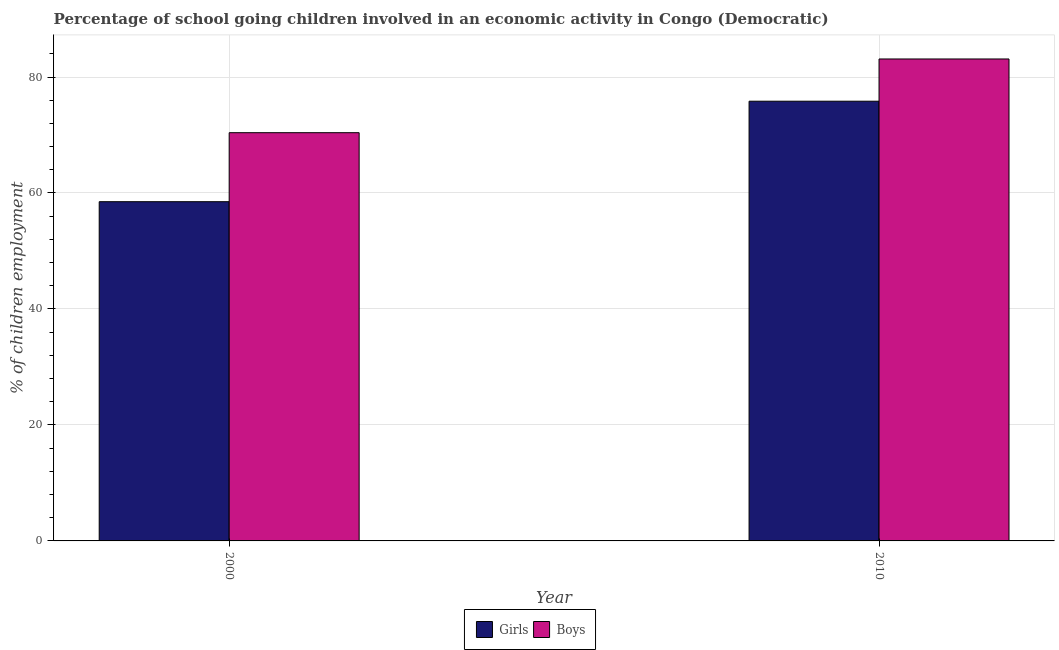How many groups of bars are there?
Offer a very short reply. 2. Are the number of bars per tick equal to the number of legend labels?
Offer a terse response. Yes. Are the number of bars on each tick of the X-axis equal?
Offer a very short reply. Yes. What is the label of the 2nd group of bars from the left?
Your response must be concise. 2010. In how many cases, is the number of bars for a given year not equal to the number of legend labels?
Your answer should be compact. 0. What is the percentage of school going girls in 2010?
Ensure brevity in your answer.  75.83. Across all years, what is the maximum percentage of school going boys?
Ensure brevity in your answer.  83.11. Across all years, what is the minimum percentage of school going girls?
Provide a short and direct response. 58.5. What is the total percentage of school going boys in the graph?
Provide a succinct answer. 153.51. What is the difference between the percentage of school going boys in 2000 and that in 2010?
Provide a succinct answer. -12.71. What is the difference between the percentage of school going boys in 2010 and the percentage of school going girls in 2000?
Provide a short and direct response. 12.71. What is the average percentage of school going girls per year?
Give a very brief answer. 67.16. In the year 2000, what is the difference between the percentage of school going girls and percentage of school going boys?
Provide a succinct answer. 0. In how many years, is the percentage of school going girls greater than 20 %?
Give a very brief answer. 2. What is the ratio of the percentage of school going boys in 2000 to that in 2010?
Provide a short and direct response. 0.85. Is the percentage of school going girls in 2000 less than that in 2010?
Offer a terse response. Yes. In how many years, is the percentage of school going boys greater than the average percentage of school going boys taken over all years?
Keep it short and to the point. 1. What does the 2nd bar from the left in 2010 represents?
Ensure brevity in your answer.  Boys. What does the 1st bar from the right in 2000 represents?
Provide a succinct answer. Boys. How many bars are there?
Provide a succinct answer. 4. How many years are there in the graph?
Offer a very short reply. 2. What is the difference between two consecutive major ticks on the Y-axis?
Provide a succinct answer. 20. How many legend labels are there?
Provide a succinct answer. 2. How are the legend labels stacked?
Offer a terse response. Horizontal. What is the title of the graph?
Your response must be concise. Percentage of school going children involved in an economic activity in Congo (Democratic). Does "RDB concessional" appear as one of the legend labels in the graph?
Ensure brevity in your answer.  No. What is the label or title of the Y-axis?
Ensure brevity in your answer.  % of children employment. What is the % of children employment in Girls in 2000?
Provide a short and direct response. 58.5. What is the % of children employment of Boys in 2000?
Ensure brevity in your answer.  70.4. What is the % of children employment in Girls in 2010?
Your answer should be very brief. 75.83. What is the % of children employment in Boys in 2010?
Offer a terse response. 83.11. Across all years, what is the maximum % of children employment in Girls?
Keep it short and to the point. 75.83. Across all years, what is the maximum % of children employment of Boys?
Keep it short and to the point. 83.11. Across all years, what is the minimum % of children employment of Girls?
Your response must be concise. 58.5. Across all years, what is the minimum % of children employment of Boys?
Your answer should be compact. 70.4. What is the total % of children employment in Girls in the graph?
Offer a terse response. 134.33. What is the total % of children employment of Boys in the graph?
Your answer should be compact. 153.51. What is the difference between the % of children employment of Girls in 2000 and that in 2010?
Give a very brief answer. -17.33. What is the difference between the % of children employment in Boys in 2000 and that in 2010?
Make the answer very short. -12.71. What is the difference between the % of children employment of Girls in 2000 and the % of children employment of Boys in 2010?
Your response must be concise. -24.61. What is the average % of children employment of Girls per year?
Make the answer very short. 67.16. What is the average % of children employment in Boys per year?
Provide a succinct answer. 76.76. In the year 2010, what is the difference between the % of children employment in Girls and % of children employment in Boys?
Your response must be concise. -7.29. What is the ratio of the % of children employment of Girls in 2000 to that in 2010?
Give a very brief answer. 0.77. What is the ratio of the % of children employment in Boys in 2000 to that in 2010?
Ensure brevity in your answer.  0.85. What is the difference between the highest and the second highest % of children employment in Girls?
Provide a succinct answer. 17.33. What is the difference between the highest and the second highest % of children employment in Boys?
Ensure brevity in your answer.  12.71. What is the difference between the highest and the lowest % of children employment in Girls?
Offer a terse response. 17.33. What is the difference between the highest and the lowest % of children employment of Boys?
Your response must be concise. 12.71. 